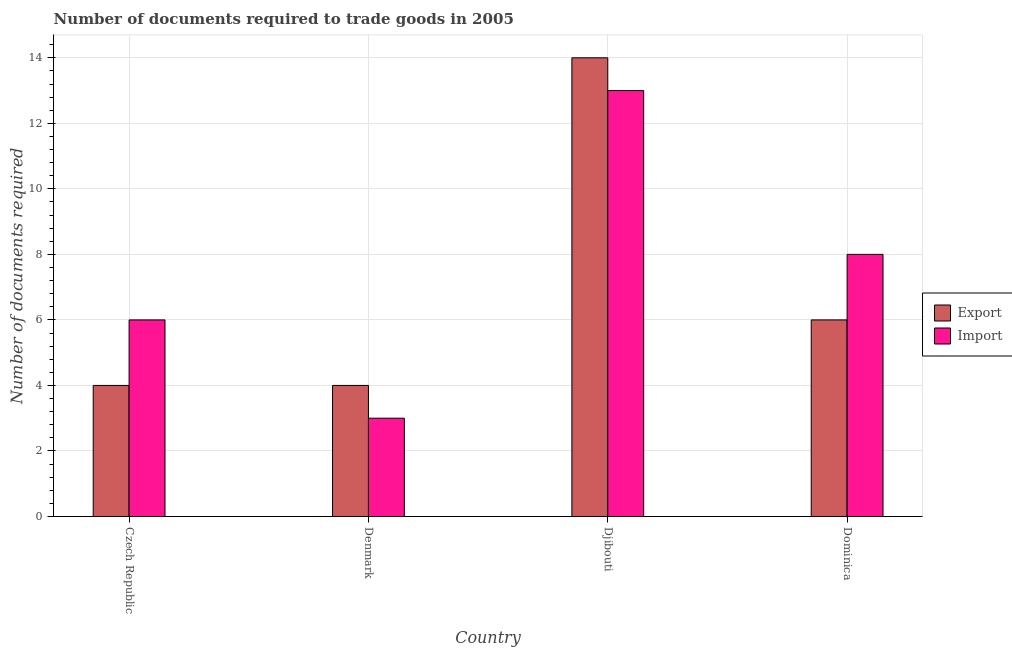How many groups of bars are there?
Your response must be concise. 4. Are the number of bars per tick equal to the number of legend labels?
Make the answer very short. Yes. How many bars are there on the 2nd tick from the left?
Ensure brevity in your answer.  2. How many bars are there on the 4th tick from the right?
Ensure brevity in your answer.  2. What is the label of the 4th group of bars from the left?
Your answer should be compact. Dominica. In how many cases, is the number of bars for a given country not equal to the number of legend labels?
Your answer should be very brief. 0. Across all countries, what is the maximum number of documents required to import goods?
Your answer should be very brief. 13. In which country was the number of documents required to export goods maximum?
Your answer should be very brief. Djibouti. What is the difference between the number of documents required to import goods in Czech Republic and that in Denmark?
Your answer should be compact. 3. What is the difference between the number of documents required to export goods in Djibouti and the number of documents required to import goods in Czech Republic?
Make the answer very short. 8. What is the average number of documents required to import goods per country?
Provide a short and direct response. 7.5. What is the difference between the number of documents required to import goods and number of documents required to export goods in Djibouti?
Ensure brevity in your answer.  -1. In how many countries, is the number of documents required to export goods greater than 0.4 ?
Your response must be concise. 4. What is the ratio of the number of documents required to export goods in Denmark to that in Djibouti?
Your response must be concise. 0.29. Is the difference between the number of documents required to import goods in Czech Republic and Denmark greater than the difference between the number of documents required to export goods in Czech Republic and Denmark?
Your answer should be compact. Yes. What is the difference between the highest and the second highest number of documents required to import goods?
Your answer should be compact. 5. In how many countries, is the number of documents required to export goods greater than the average number of documents required to export goods taken over all countries?
Provide a short and direct response. 1. What does the 2nd bar from the left in Czech Republic represents?
Your response must be concise. Import. What does the 2nd bar from the right in Dominica represents?
Give a very brief answer. Export. How many bars are there?
Offer a very short reply. 8. Are all the bars in the graph horizontal?
Your answer should be compact. No. How many countries are there in the graph?
Offer a very short reply. 4. Are the values on the major ticks of Y-axis written in scientific E-notation?
Provide a short and direct response. No. Does the graph contain any zero values?
Make the answer very short. No. Does the graph contain grids?
Make the answer very short. Yes. What is the title of the graph?
Provide a short and direct response. Number of documents required to trade goods in 2005. What is the label or title of the X-axis?
Offer a terse response. Country. What is the label or title of the Y-axis?
Give a very brief answer. Number of documents required. What is the Number of documents required of Export in Czech Republic?
Give a very brief answer. 4. What is the Number of documents required in Import in Czech Republic?
Ensure brevity in your answer.  6. What is the Number of documents required in Export in Denmark?
Your response must be concise. 4. Across all countries, what is the maximum Number of documents required in Export?
Ensure brevity in your answer.  14. Across all countries, what is the maximum Number of documents required in Import?
Give a very brief answer. 13. Across all countries, what is the minimum Number of documents required in Export?
Ensure brevity in your answer.  4. What is the total Number of documents required of Export in the graph?
Give a very brief answer. 28. What is the total Number of documents required in Import in the graph?
Your response must be concise. 30. What is the difference between the Number of documents required of Export in Czech Republic and that in Denmark?
Ensure brevity in your answer.  0. What is the difference between the Number of documents required in Export in Czech Republic and that in Djibouti?
Your response must be concise. -10. What is the difference between the Number of documents required in Export in Denmark and that in Djibouti?
Your response must be concise. -10. What is the difference between the Number of documents required of Export in Denmark and that in Dominica?
Your response must be concise. -2. What is the difference between the Number of documents required of Import in Denmark and that in Dominica?
Provide a succinct answer. -5. What is the difference between the Number of documents required of Import in Djibouti and that in Dominica?
Ensure brevity in your answer.  5. What is the difference between the Number of documents required in Export in Czech Republic and the Number of documents required in Import in Denmark?
Your answer should be very brief. 1. What is the difference between the Number of documents required of Export in Czech Republic and the Number of documents required of Import in Djibouti?
Offer a terse response. -9. What is the difference between the Number of documents required in Export in Czech Republic and the Number of documents required in Import in Dominica?
Your answer should be compact. -4. What is the difference between the Number of documents required in Export in Djibouti and the Number of documents required in Import in Dominica?
Offer a terse response. 6. What is the average Number of documents required in Export per country?
Your answer should be very brief. 7. What is the difference between the Number of documents required of Export and Number of documents required of Import in Denmark?
Offer a terse response. 1. What is the difference between the Number of documents required in Export and Number of documents required in Import in Dominica?
Your answer should be very brief. -2. What is the ratio of the Number of documents required in Import in Czech Republic to that in Denmark?
Your answer should be compact. 2. What is the ratio of the Number of documents required in Export in Czech Republic to that in Djibouti?
Make the answer very short. 0.29. What is the ratio of the Number of documents required of Import in Czech Republic to that in Djibouti?
Provide a succinct answer. 0.46. What is the ratio of the Number of documents required in Export in Czech Republic to that in Dominica?
Give a very brief answer. 0.67. What is the ratio of the Number of documents required in Export in Denmark to that in Djibouti?
Offer a very short reply. 0.29. What is the ratio of the Number of documents required in Import in Denmark to that in Djibouti?
Offer a terse response. 0.23. What is the ratio of the Number of documents required of Export in Denmark to that in Dominica?
Your response must be concise. 0.67. What is the ratio of the Number of documents required in Import in Denmark to that in Dominica?
Keep it short and to the point. 0.38. What is the ratio of the Number of documents required of Export in Djibouti to that in Dominica?
Offer a terse response. 2.33. What is the ratio of the Number of documents required of Import in Djibouti to that in Dominica?
Your answer should be compact. 1.62. What is the difference between the highest and the second highest Number of documents required in Export?
Make the answer very short. 8. What is the difference between the highest and the second highest Number of documents required in Import?
Your answer should be very brief. 5. What is the difference between the highest and the lowest Number of documents required in Export?
Give a very brief answer. 10. What is the difference between the highest and the lowest Number of documents required of Import?
Offer a terse response. 10. 